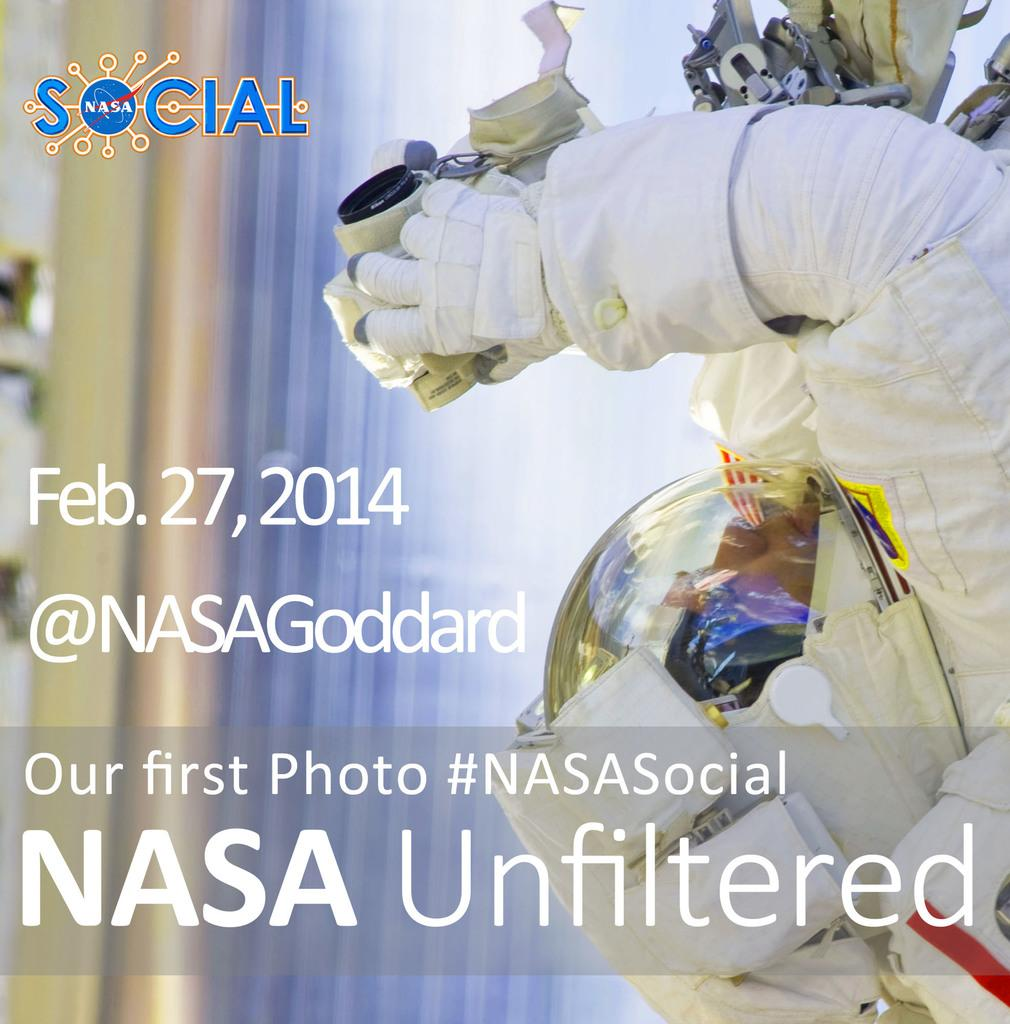What is the main subject of the image? There is an astronaut in the image. What is the astronaut doing in the image? The astronaut is holding an object. What else can be seen in the image besides the astronaut? There is text visible in the image, as well as a logo. What type of paste is the astronaut using to stick the crate to the wall in the image? There is no paste or crate present in the image; the astronaut is holding an object, and there is text and a logo visible. 